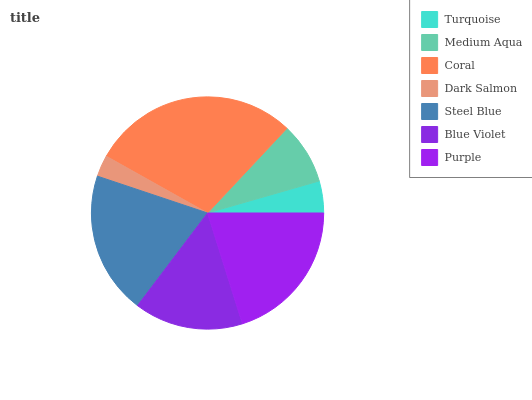Is Dark Salmon the minimum?
Answer yes or no. Yes. Is Coral the maximum?
Answer yes or no. Yes. Is Medium Aqua the minimum?
Answer yes or no. No. Is Medium Aqua the maximum?
Answer yes or no. No. Is Medium Aqua greater than Turquoise?
Answer yes or no. Yes. Is Turquoise less than Medium Aqua?
Answer yes or no. Yes. Is Turquoise greater than Medium Aqua?
Answer yes or no. No. Is Medium Aqua less than Turquoise?
Answer yes or no. No. Is Blue Violet the high median?
Answer yes or no. Yes. Is Blue Violet the low median?
Answer yes or no. Yes. Is Coral the high median?
Answer yes or no. No. Is Dark Salmon the low median?
Answer yes or no. No. 